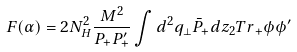Convert formula to latex. <formula><loc_0><loc_0><loc_500><loc_500>F ( \alpha ) = 2 N _ { H } ^ { 2 } { \frac { M ^ { 2 } } { P _ { + } P _ { + } ^ { \prime } } } \int d ^ { 2 } q _ { \perp } { \bar { P } } _ { + } d z _ { 2 } { T r } _ { + } \phi \phi ^ { \prime }</formula> 